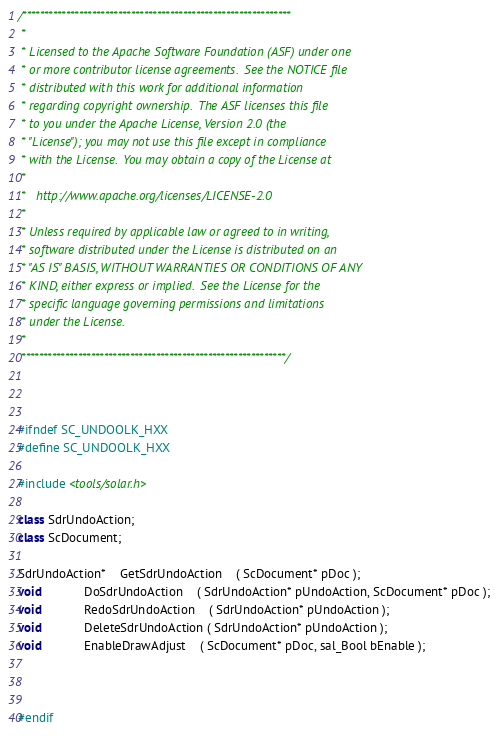Convert code to text. <code><loc_0><loc_0><loc_500><loc_500><_C++_>/**************************************************************
 * 
 * Licensed to the Apache Software Foundation (ASF) under one
 * or more contributor license agreements.  See the NOTICE file
 * distributed with this work for additional information
 * regarding copyright ownership.  The ASF licenses this file
 * to you under the Apache License, Version 2.0 (the
 * "License"); you may not use this file except in compliance
 * with the License.  You may obtain a copy of the License at
 * 
 *   http://www.apache.org/licenses/LICENSE-2.0
 * 
 * Unless required by applicable law or agreed to in writing,
 * software distributed under the License is distributed on an
 * "AS IS" BASIS, WITHOUT WARRANTIES OR CONDITIONS OF ANY
 * KIND, either express or implied.  See the License for the
 * specific language governing permissions and limitations
 * under the License.
 * 
 *************************************************************/



#ifndef SC_UNDOOLK_HXX
#define SC_UNDOOLK_HXX

#include <tools/solar.h>

class SdrUndoAction;
class ScDocument;

SdrUndoAction*	GetSdrUndoAction	( ScDocument* pDoc );
void			DoSdrUndoAction 	( SdrUndoAction* pUndoAction, ScDocument* pDoc );
void			RedoSdrUndoAction 	( SdrUndoAction* pUndoAction );
void			DeleteSdrUndoAction ( SdrUndoAction* pUndoAction );
void			EnableDrawAdjust	( ScDocument* pDoc, sal_Bool bEnable );



#endif
</code> 